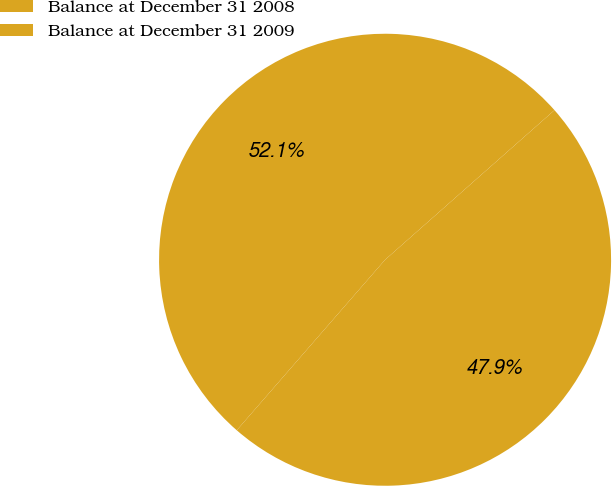Convert chart. <chart><loc_0><loc_0><loc_500><loc_500><pie_chart><fcel>Balance at December 31 2008<fcel>Balance at December 31 2009<nl><fcel>52.09%<fcel>47.91%<nl></chart> 